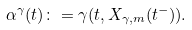Convert formula to latex. <formula><loc_0><loc_0><loc_500><loc_500>\alpha ^ { \gamma } ( t ) \colon = \gamma ( t , X _ { \gamma , m } ( t ^ { - } ) ) .</formula> 